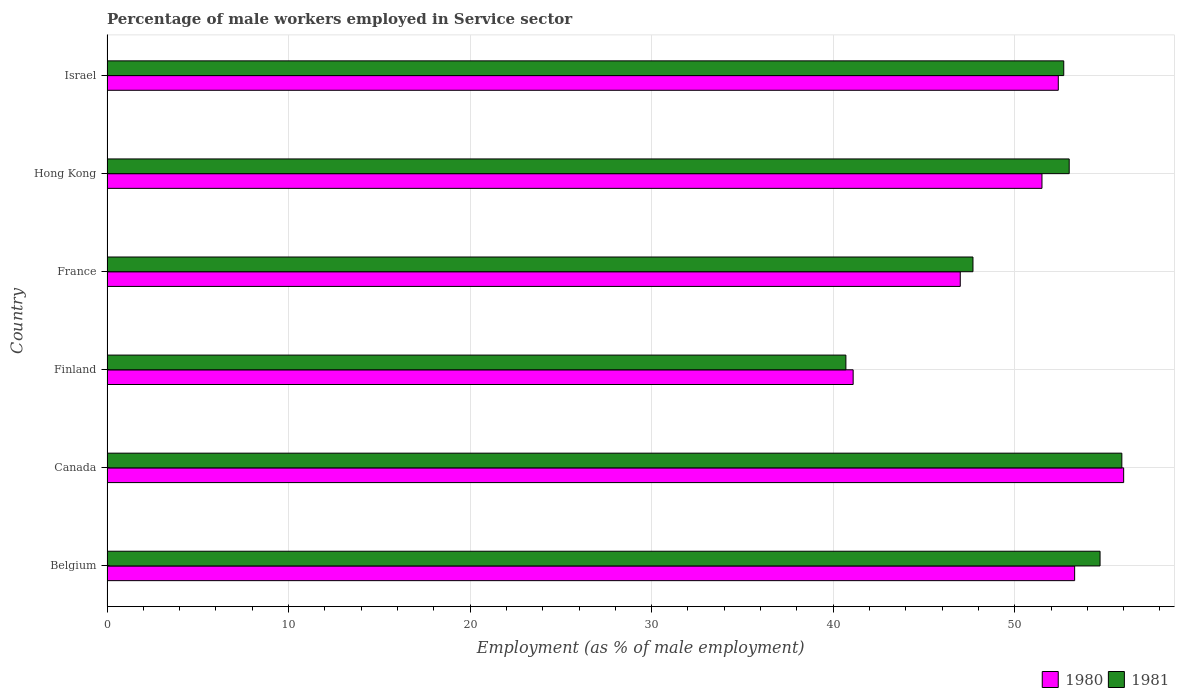How many different coloured bars are there?
Keep it short and to the point. 2. Are the number of bars on each tick of the Y-axis equal?
Ensure brevity in your answer.  Yes. How many bars are there on the 6th tick from the top?
Make the answer very short. 2. How many bars are there on the 2nd tick from the bottom?
Ensure brevity in your answer.  2. What is the label of the 6th group of bars from the top?
Your response must be concise. Belgium. In how many cases, is the number of bars for a given country not equal to the number of legend labels?
Your answer should be very brief. 0. What is the percentage of male workers employed in Service sector in 1980 in Israel?
Your answer should be compact. 52.4. Across all countries, what is the maximum percentage of male workers employed in Service sector in 1980?
Your answer should be very brief. 56. Across all countries, what is the minimum percentage of male workers employed in Service sector in 1981?
Offer a very short reply. 40.7. In which country was the percentage of male workers employed in Service sector in 1981 maximum?
Give a very brief answer. Canada. In which country was the percentage of male workers employed in Service sector in 1981 minimum?
Your answer should be compact. Finland. What is the total percentage of male workers employed in Service sector in 1981 in the graph?
Provide a short and direct response. 304.7. What is the difference between the percentage of male workers employed in Service sector in 1980 in Finland and the percentage of male workers employed in Service sector in 1981 in Canada?
Make the answer very short. -14.8. What is the average percentage of male workers employed in Service sector in 1980 per country?
Your answer should be very brief. 50.22. What is the difference between the percentage of male workers employed in Service sector in 1981 and percentage of male workers employed in Service sector in 1980 in Belgium?
Your answer should be compact. 1.4. What is the ratio of the percentage of male workers employed in Service sector in 1981 in Belgium to that in Finland?
Give a very brief answer. 1.34. What is the difference between the highest and the second highest percentage of male workers employed in Service sector in 1981?
Provide a succinct answer. 1.2. What is the difference between the highest and the lowest percentage of male workers employed in Service sector in 1981?
Keep it short and to the point. 15.2. In how many countries, is the percentage of male workers employed in Service sector in 1980 greater than the average percentage of male workers employed in Service sector in 1980 taken over all countries?
Make the answer very short. 4. Is the sum of the percentage of male workers employed in Service sector in 1981 in Finland and Israel greater than the maximum percentage of male workers employed in Service sector in 1980 across all countries?
Give a very brief answer. Yes. What does the 1st bar from the top in France represents?
Make the answer very short. 1981. What does the 2nd bar from the bottom in Israel represents?
Your answer should be very brief. 1981. How many bars are there?
Offer a terse response. 12. How many countries are there in the graph?
Provide a succinct answer. 6. What is the difference between two consecutive major ticks on the X-axis?
Offer a terse response. 10. Does the graph contain any zero values?
Offer a very short reply. No. Does the graph contain grids?
Make the answer very short. Yes. Where does the legend appear in the graph?
Make the answer very short. Bottom right. How are the legend labels stacked?
Provide a short and direct response. Horizontal. What is the title of the graph?
Your response must be concise. Percentage of male workers employed in Service sector. Does "1984" appear as one of the legend labels in the graph?
Your answer should be compact. No. What is the label or title of the X-axis?
Your answer should be compact. Employment (as % of male employment). What is the label or title of the Y-axis?
Make the answer very short. Country. What is the Employment (as % of male employment) of 1980 in Belgium?
Ensure brevity in your answer.  53.3. What is the Employment (as % of male employment) in 1981 in Belgium?
Your answer should be very brief. 54.7. What is the Employment (as % of male employment) of 1980 in Canada?
Provide a succinct answer. 56. What is the Employment (as % of male employment) of 1981 in Canada?
Give a very brief answer. 55.9. What is the Employment (as % of male employment) in 1980 in Finland?
Provide a succinct answer. 41.1. What is the Employment (as % of male employment) in 1981 in Finland?
Your answer should be compact. 40.7. What is the Employment (as % of male employment) of 1980 in France?
Make the answer very short. 47. What is the Employment (as % of male employment) in 1981 in France?
Your answer should be very brief. 47.7. What is the Employment (as % of male employment) in 1980 in Hong Kong?
Give a very brief answer. 51.5. What is the Employment (as % of male employment) of 1980 in Israel?
Keep it short and to the point. 52.4. What is the Employment (as % of male employment) in 1981 in Israel?
Your answer should be compact. 52.7. Across all countries, what is the maximum Employment (as % of male employment) of 1980?
Your response must be concise. 56. Across all countries, what is the maximum Employment (as % of male employment) in 1981?
Offer a very short reply. 55.9. Across all countries, what is the minimum Employment (as % of male employment) in 1980?
Provide a short and direct response. 41.1. Across all countries, what is the minimum Employment (as % of male employment) of 1981?
Make the answer very short. 40.7. What is the total Employment (as % of male employment) in 1980 in the graph?
Your answer should be very brief. 301.3. What is the total Employment (as % of male employment) of 1981 in the graph?
Make the answer very short. 304.7. What is the difference between the Employment (as % of male employment) of 1980 in Belgium and that in Canada?
Offer a very short reply. -2.7. What is the difference between the Employment (as % of male employment) of 1981 in Belgium and that in Canada?
Offer a terse response. -1.2. What is the difference between the Employment (as % of male employment) in 1981 in Belgium and that in Finland?
Your response must be concise. 14. What is the difference between the Employment (as % of male employment) in 1980 in Belgium and that in France?
Offer a very short reply. 6.3. What is the difference between the Employment (as % of male employment) in 1980 in Belgium and that in Hong Kong?
Ensure brevity in your answer.  1.8. What is the difference between the Employment (as % of male employment) in 1981 in Belgium and that in Hong Kong?
Offer a very short reply. 1.7. What is the difference between the Employment (as % of male employment) of 1980 in Belgium and that in Israel?
Provide a succinct answer. 0.9. What is the difference between the Employment (as % of male employment) of 1981 in Belgium and that in Israel?
Ensure brevity in your answer.  2. What is the difference between the Employment (as % of male employment) in 1980 in Canada and that in Finland?
Provide a succinct answer. 14.9. What is the difference between the Employment (as % of male employment) of 1981 in Canada and that in France?
Provide a succinct answer. 8.2. What is the difference between the Employment (as % of male employment) of 1981 in Canada and that in Hong Kong?
Give a very brief answer. 2.9. What is the difference between the Employment (as % of male employment) in 1980 in Canada and that in Israel?
Keep it short and to the point. 3.6. What is the difference between the Employment (as % of male employment) of 1981 in Canada and that in Israel?
Make the answer very short. 3.2. What is the difference between the Employment (as % of male employment) of 1980 in Finland and that in Hong Kong?
Your answer should be very brief. -10.4. What is the difference between the Employment (as % of male employment) of 1981 in Finland and that in Hong Kong?
Offer a terse response. -12.3. What is the difference between the Employment (as % of male employment) in 1980 in Finland and that in Israel?
Offer a terse response. -11.3. What is the difference between the Employment (as % of male employment) of 1980 in France and that in Hong Kong?
Give a very brief answer. -4.5. What is the difference between the Employment (as % of male employment) in 1980 in France and that in Israel?
Provide a succinct answer. -5.4. What is the difference between the Employment (as % of male employment) in 1981 in France and that in Israel?
Your answer should be compact. -5. What is the difference between the Employment (as % of male employment) in 1980 in Belgium and the Employment (as % of male employment) in 1981 in Canada?
Keep it short and to the point. -2.6. What is the difference between the Employment (as % of male employment) of 1980 in Belgium and the Employment (as % of male employment) of 1981 in Finland?
Give a very brief answer. 12.6. What is the difference between the Employment (as % of male employment) in 1980 in Belgium and the Employment (as % of male employment) in 1981 in France?
Your answer should be compact. 5.6. What is the difference between the Employment (as % of male employment) in 1980 in Belgium and the Employment (as % of male employment) in 1981 in Hong Kong?
Provide a short and direct response. 0.3. What is the difference between the Employment (as % of male employment) in 1980 in Canada and the Employment (as % of male employment) in 1981 in Finland?
Make the answer very short. 15.3. What is the difference between the Employment (as % of male employment) in 1980 in Canada and the Employment (as % of male employment) in 1981 in France?
Offer a terse response. 8.3. What is the difference between the Employment (as % of male employment) in 1980 in Canada and the Employment (as % of male employment) in 1981 in Hong Kong?
Make the answer very short. 3. What is the difference between the Employment (as % of male employment) in 1980 in Canada and the Employment (as % of male employment) in 1981 in Israel?
Give a very brief answer. 3.3. What is the difference between the Employment (as % of male employment) of 1980 in Finland and the Employment (as % of male employment) of 1981 in France?
Make the answer very short. -6.6. What is the difference between the Employment (as % of male employment) of 1980 in France and the Employment (as % of male employment) of 1981 in Israel?
Provide a succinct answer. -5.7. What is the difference between the Employment (as % of male employment) of 1980 in Hong Kong and the Employment (as % of male employment) of 1981 in Israel?
Your answer should be very brief. -1.2. What is the average Employment (as % of male employment) of 1980 per country?
Offer a very short reply. 50.22. What is the average Employment (as % of male employment) in 1981 per country?
Keep it short and to the point. 50.78. What is the difference between the Employment (as % of male employment) of 1980 and Employment (as % of male employment) of 1981 in Israel?
Your answer should be compact. -0.3. What is the ratio of the Employment (as % of male employment) in 1980 in Belgium to that in Canada?
Provide a succinct answer. 0.95. What is the ratio of the Employment (as % of male employment) of 1981 in Belgium to that in Canada?
Offer a terse response. 0.98. What is the ratio of the Employment (as % of male employment) in 1980 in Belgium to that in Finland?
Offer a terse response. 1.3. What is the ratio of the Employment (as % of male employment) of 1981 in Belgium to that in Finland?
Your answer should be compact. 1.34. What is the ratio of the Employment (as % of male employment) in 1980 in Belgium to that in France?
Give a very brief answer. 1.13. What is the ratio of the Employment (as % of male employment) in 1981 in Belgium to that in France?
Your answer should be very brief. 1.15. What is the ratio of the Employment (as % of male employment) of 1980 in Belgium to that in Hong Kong?
Offer a terse response. 1.03. What is the ratio of the Employment (as % of male employment) of 1981 in Belgium to that in Hong Kong?
Your answer should be very brief. 1.03. What is the ratio of the Employment (as % of male employment) in 1980 in Belgium to that in Israel?
Provide a succinct answer. 1.02. What is the ratio of the Employment (as % of male employment) of 1981 in Belgium to that in Israel?
Offer a terse response. 1.04. What is the ratio of the Employment (as % of male employment) of 1980 in Canada to that in Finland?
Keep it short and to the point. 1.36. What is the ratio of the Employment (as % of male employment) in 1981 in Canada to that in Finland?
Provide a short and direct response. 1.37. What is the ratio of the Employment (as % of male employment) of 1980 in Canada to that in France?
Your response must be concise. 1.19. What is the ratio of the Employment (as % of male employment) in 1981 in Canada to that in France?
Give a very brief answer. 1.17. What is the ratio of the Employment (as % of male employment) of 1980 in Canada to that in Hong Kong?
Provide a short and direct response. 1.09. What is the ratio of the Employment (as % of male employment) in 1981 in Canada to that in Hong Kong?
Your answer should be very brief. 1.05. What is the ratio of the Employment (as % of male employment) of 1980 in Canada to that in Israel?
Your answer should be very brief. 1.07. What is the ratio of the Employment (as % of male employment) in 1981 in Canada to that in Israel?
Keep it short and to the point. 1.06. What is the ratio of the Employment (as % of male employment) in 1980 in Finland to that in France?
Make the answer very short. 0.87. What is the ratio of the Employment (as % of male employment) in 1981 in Finland to that in France?
Give a very brief answer. 0.85. What is the ratio of the Employment (as % of male employment) of 1980 in Finland to that in Hong Kong?
Provide a short and direct response. 0.8. What is the ratio of the Employment (as % of male employment) in 1981 in Finland to that in Hong Kong?
Provide a short and direct response. 0.77. What is the ratio of the Employment (as % of male employment) in 1980 in Finland to that in Israel?
Make the answer very short. 0.78. What is the ratio of the Employment (as % of male employment) of 1981 in Finland to that in Israel?
Keep it short and to the point. 0.77. What is the ratio of the Employment (as % of male employment) in 1980 in France to that in Hong Kong?
Keep it short and to the point. 0.91. What is the ratio of the Employment (as % of male employment) of 1981 in France to that in Hong Kong?
Keep it short and to the point. 0.9. What is the ratio of the Employment (as % of male employment) of 1980 in France to that in Israel?
Keep it short and to the point. 0.9. What is the ratio of the Employment (as % of male employment) of 1981 in France to that in Israel?
Your answer should be compact. 0.91. What is the ratio of the Employment (as % of male employment) in 1980 in Hong Kong to that in Israel?
Ensure brevity in your answer.  0.98. 